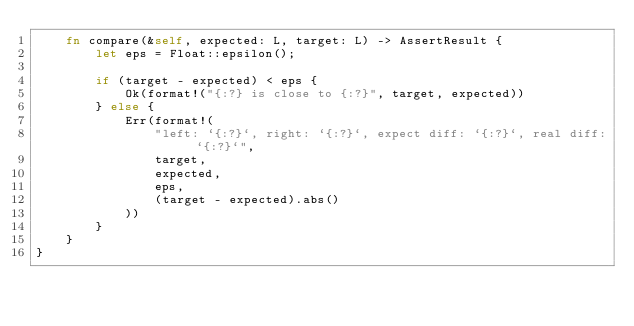<code> <loc_0><loc_0><loc_500><loc_500><_Rust_>    fn compare(&self, expected: L, target: L) -> AssertResult {
        let eps = Float::epsilon();

        if (target - expected) < eps {
            Ok(format!("{:?} is close to {:?}", target, expected))
        } else {
            Err(format!(
                "left: `{:?}`, right: `{:?}`, expect diff: `{:?}`, real diff: `{:?}`",
                target,
                expected,
                eps,
                (target - expected).abs()
            ))
        }
    }
}
</code> 